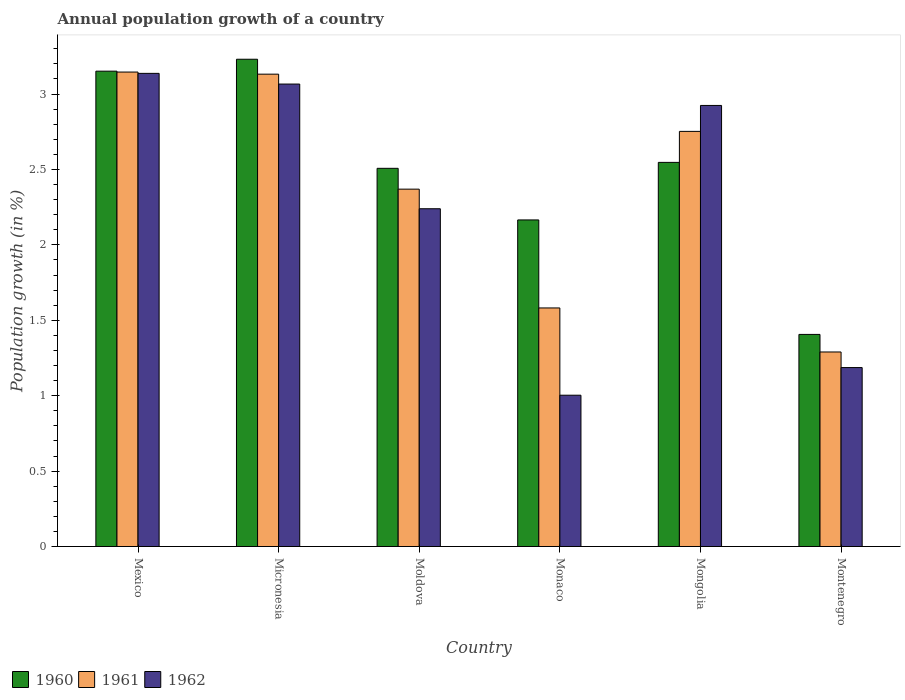How many groups of bars are there?
Provide a succinct answer. 6. Are the number of bars per tick equal to the number of legend labels?
Provide a short and direct response. Yes. Are the number of bars on each tick of the X-axis equal?
Ensure brevity in your answer.  Yes. How many bars are there on the 1st tick from the right?
Offer a very short reply. 3. What is the annual population growth in 1960 in Micronesia?
Provide a succinct answer. 3.23. Across all countries, what is the maximum annual population growth in 1962?
Offer a very short reply. 3.14. Across all countries, what is the minimum annual population growth in 1962?
Your response must be concise. 1. In which country was the annual population growth in 1960 maximum?
Make the answer very short. Micronesia. In which country was the annual population growth in 1962 minimum?
Offer a very short reply. Monaco. What is the total annual population growth in 1960 in the graph?
Keep it short and to the point. 15.01. What is the difference between the annual population growth in 1960 in Moldova and that in Montenegro?
Keep it short and to the point. 1.1. What is the difference between the annual population growth in 1961 in Micronesia and the annual population growth in 1962 in Mongolia?
Your response must be concise. 0.21. What is the average annual population growth in 1960 per country?
Provide a short and direct response. 2.5. What is the difference between the annual population growth of/in 1961 and annual population growth of/in 1962 in Micronesia?
Give a very brief answer. 0.07. In how many countries, is the annual population growth in 1962 greater than 1.4 %?
Your response must be concise. 4. What is the ratio of the annual population growth in 1962 in Mongolia to that in Montenegro?
Offer a terse response. 2.46. Is the annual population growth in 1961 in Moldova less than that in Mongolia?
Offer a terse response. Yes. What is the difference between the highest and the second highest annual population growth in 1960?
Keep it short and to the point. 0.6. What is the difference between the highest and the lowest annual population growth in 1960?
Keep it short and to the point. 1.82. In how many countries, is the annual population growth in 1962 greater than the average annual population growth in 1962 taken over all countries?
Give a very brief answer. 3. What does the 1st bar from the right in Mexico represents?
Provide a succinct answer. 1962. Is it the case that in every country, the sum of the annual population growth in 1960 and annual population growth in 1962 is greater than the annual population growth in 1961?
Offer a terse response. Yes. How many bars are there?
Offer a terse response. 18. Are all the bars in the graph horizontal?
Your answer should be very brief. No. Does the graph contain any zero values?
Make the answer very short. No. Does the graph contain grids?
Your answer should be compact. No. Where does the legend appear in the graph?
Offer a very short reply. Bottom left. How many legend labels are there?
Provide a succinct answer. 3. How are the legend labels stacked?
Your answer should be compact. Horizontal. What is the title of the graph?
Offer a terse response. Annual population growth of a country. Does "1971" appear as one of the legend labels in the graph?
Ensure brevity in your answer.  No. What is the label or title of the Y-axis?
Your response must be concise. Population growth (in %). What is the Population growth (in %) in 1960 in Mexico?
Offer a very short reply. 3.15. What is the Population growth (in %) of 1961 in Mexico?
Offer a very short reply. 3.15. What is the Population growth (in %) in 1962 in Mexico?
Keep it short and to the point. 3.14. What is the Population growth (in %) in 1960 in Micronesia?
Give a very brief answer. 3.23. What is the Population growth (in %) in 1961 in Micronesia?
Give a very brief answer. 3.13. What is the Population growth (in %) in 1962 in Micronesia?
Your answer should be compact. 3.07. What is the Population growth (in %) of 1960 in Moldova?
Keep it short and to the point. 2.51. What is the Population growth (in %) of 1961 in Moldova?
Give a very brief answer. 2.37. What is the Population growth (in %) of 1962 in Moldova?
Ensure brevity in your answer.  2.24. What is the Population growth (in %) in 1960 in Monaco?
Provide a short and direct response. 2.17. What is the Population growth (in %) of 1961 in Monaco?
Your answer should be very brief. 1.58. What is the Population growth (in %) of 1962 in Monaco?
Offer a terse response. 1. What is the Population growth (in %) of 1960 in Mongolia?
Give a very brief answer. 2.55. What is the Population growth (in %) in 1961 in Mongolia?
Your response must be concise. 2.75. What is the Population growth (in %) in 1962 in Mongolia?
Your answer should be compact. 2.92. What is the Population growth (in %) of 1960 in Montenegro?
Your answer should be very brief. 1.41. What is the Population growth (in %) in 1961 in Montenegro?
Offer a terse response. 1.29. What is the Population growth (in %) of 1962 in Montenegro?
Your response must be concise. 1.19. Across all countries, what is the maximum Population growth (in %) of 1960?
Keep it short and to the point. 3.23. Across all countries, what is the maximum Population growth (in %) in 1961?
Provide a short and direct response. 3.15. Across all countries, what is the maximum Population growth (in %) in 1962?
Make the answer very short. 3.14. Across all countries, what is the minimum Population growth (in %) of 1960?
Your response must be concise. 1.41. Across all countries, what is the minimum Population growth (in %) of 1961?
Your answer should be compact. 1.29. Across all countries, what is the minimum Population growth (in %) of 1962?
Ensure brevity in your answer.  1. What is the total Population growth (in %) of 1960 in the graph?
Make the answer very short. 15.01. What is the total Population growth (in %) of 1961 in the graph?
Your answer should be very brief. 14.27. What is the total Population growth (in %) in 1962 in the graph?
Ensure brevity in your answer.  13.56. What is the difference between the Population growth (in %) in 1960 in Mexico and that in Micronesia?
Provide a succinct answer. -0.08. What is the difference between the Population growth (in %) of 1961 in Mexico and that in Micronesia?
Your answer should be very brief. 0.01. What is the difference between the Population growth (in %) in 1962 in Mexico and that in Micronesia?
Provide a short and direct response. 0.07. What is the difference between the Population growth (in %) in 1960 in Mexico and that in Moldova?
Provide a short and direct response. 0.64. What is the difference between the Population growth (in %) of 1961 in Mexico and that in Moldova?
Provide a short and direct response. 0.78. What is the difference between the Population growth (in %) in 1962 in Mexico and that in Moldova?
Make the answer very short. 0.9. What is the difference between the Population growth (in %) of 1960 in Mexico and that in Monaco?
Ensure brevity in your answer.  0.99. What is the difference between the Population growth (in %) of 1961 in Mexico and that in Monaco?
Provide a short and direct response. 1.56. What is the difference between the Population growth (in %) of 1962 in Mexico and that in Monaco?
Give a very brief answer. 2.13. What is the difference between the Population growth (in %) of 1960 in Mexico and that in Mongolia?
Ensure brevity in your answer.  0.6. What is the difference between the Population growth (in %) of 1961 in Mexico and that in Mongolia?
Offer a terse response. 0.39. What is the difference between the Population growth (in %) in 1962 in Mexico and that in Mongolia?
Make the answer very short. 0.21. What is the difference between the Population growth (in %) of 1960 in Mexico and that in Montenegro?
Your response must be concise. 1.75. What is the difference between the Population growth (in %) in 1961 in Mexico and that in Montenegro?
Offer a very short reply. 1.86. What is the difference between the Population growth (in %) of 1962 in Mexico and that in Montenegro?
Offer a very short reply. 1.95. What is the difference between the Population growth (in %) in 1960 in Micronesia and that in Moldova?
Offer a very short reply. 0.72. What is the difference between the Population growth (in %) of 1961 in Micronesia and that in Moldova?
Make the answer very short. 0.76. What is the difference between the Population growth (in %) of 1962 in Micronesia and that in Moldova?
Offer a very short reply. 0.83. What is the difference between the Population growth (in %) in 1960 in Micronesia and that in Monaco?
Your answer should be compact. 1.07. What is the difference between the Population growth (in %) of 1961 in Micronesia and that in Monaco?
Your answer should be very brief. 1.55. What is the difference between the Population growth (in %) of 1962 in Micronesia and that in Monaco?
Offer a very short reply. 2.06. What is the difference between the Population growth (in %) of 1960 in Micronesia and that in Mongolia?
Ensure brevity in your answer.  0.68. What is the difference between the Population growth (in %) of 1961 in Micronesia and that in Mongolia?
Give a very brief answer. 0.38. What is the difference between the Population growth (in %) of 1962 in Micronesia and that in Mongolia?
Your answer should be compact. 0.14. What is the difference between the Population growth (in %) in 1960 in Micronesia and that in Montenegro?
Give a very brief answer. 1.82. What is the difference between the Population growth (in %) in 1961 in Micronesia and that in Montenegro?
Your answer should be compact. 1.84. What is the difference between the Population growth (in %) of 1962 in Micronesia and that in Montenegro?
Ensure brevity in your answer.  1.88. What is the difference between the Population growth (in %) of 1960 in Moldova and that in Monaco?
Give a very brief answer. 0.34. What is the difference between the Population growth (in %) in 1961 in Moldova and that in Monaco?
Your answer should be compact. 0.79. What is the difference between the Population growth (in %) of 1962 in Moldova and that in Monaco?
Make the answer very short. 1.24. What is the difference between the Population growth (in %) of 1960 in Moldova and that in Mongolia?
Your answer should be compact. -0.04. What is the difference between the Population growth (in %) of 1961 in Moldova and that in Mongolia?
Keep it short and to the point. -0.38. What is the difference between the Population growth (in %) in 1962 in Moldova and that in Mongolia?
Your answer should be very brief. -0.68. What is the difference between the Population growth (in %) of 1960 in Moldova and that in Montenegro?
Your response must be concise. 1.1. What is the difference between the Population growth (in %) of 1961 in Moldova and that in Montenegro?
Offer a terse response. 1.08. What is the difference between the Population growth (in %) of 1962 in Moldova and that in Montenegro?
Ensure brevity in your answer.  1.05. What is the difference between the Population growth (in %) in 1960 in Monaco and that in Mongolia?
Provide a short and direct response. -0.38. What is the difference between the Population growth (in %) of 1961 in Monaco and that in Mongolia?
Give a very brief answer. -1.17. What is the difference between the Population growth (in %) in 1962 in Monaco and that in Mongolia?
Offer a very short reply. -1.92. What is the difference between the Population growth (in %) of 1960 in Monaco and that in Montenegro?
Ensure brevity in your answer.  0.76. What is the difference between the Population growth (in %) of 1961 in Monaco and that in Montenegro?
Make the answer very short. 0.29. What is the difference between the Population growth (in %) in 1962 in Monaco and that in Montenegro?
Offer a terse response. -0.18. What is the difference between the Population growth (in %) in 1960 in Mongolia and that in Montenegro?
Keep it short and to the point. 1.14. What is the difference between the Population growth (in %) in 1961 in Mongolia and that in Montenegro?
Offer a very short reply. 1.46. What is the difference between the Population growth (in %) in 1962 in Mongolia and that in Montenegro?
Offer a terse response. 1.74. What is the difference between the Population growth (in %) of 1960 in Mexico and the Population growth (in %) of 1961 in Micronesia?
Provide a succinct answer. 0.02. What is the difference between the Population growth (in %) in 1960 in Mexico and the Population growth (in %) in 1962 in Micronesia?
Provide a succinct answer. 0.09. What is the difference between the Population growth (in %) in 1961 in Mexico and the Population growth (in %) in 1962 in Micronesia?
Your response must be concise. 0.08. What is the difference between the Population growth (in %) of 1960 in Mexico and the Population growth (in %) of 1961 in Moldova?
Your answer should be compact. 0.78. What is the difference between the Population growth (in %) of 1960 in Mexico and the Population growth (in %) of 1962 in Moldova?
Your answer should be very brief. 0.91. What is the difference between the Population growth (in %) in 1961 in Mexico and the Population growth (in %) in 1962 in Moldova?
Ensure brevity in your answer.  0.91. What is the difference between the Population growth (in %) in 1960 in Mexico and the Population growth (in %) in 1961 in Monaco?
Offer a terse response. 1.57. What is the difference between the Population growth (in %) of 1960 in Mexico and the Population growth (in %) of 1962 in Monaco?
Provide a succinct answer. 2.15. What is the difference between the Population growth (in %) in 1961 in Mexico and the Population growth (in %) in 1962 in Monaco?
Provide a succinct answer. 2.14. What is the difference between the Population growth (in %) in 1960 in Mexico and the Population growth (in %) in 1961 in Mongolia?
Offer a terse response. 0.4. What is the difference between the Population growth (in %) of 1960 in Mexico and the Population growth (in %) of 1962 in Mongolia?
Give a very brief answer. 0.23. What is the difference between the Population growth (in %) in 1961 in Mexico and the Population growth (in %) in 1962 in Mongolia?
Your response must be concise. 0.22. What is the difference between the Population growth (in %) of 1960 in Mexico and the Population growth (in %) of 1961 in Montenegro?
Offer a terse response. 1.86. What is the difference between the Population growth (in %) in 1960 in Mexico and the Population growth (in %) in 1962 in Montenegro?
Your answer should be compact. 1.97. What is the difference between the Population growth (in %) in 1961 in Mexico and the Population growth (in %) in 1962 in Montenegro?
Provide a succinct answer. 1.96. What is the difference between the Population growth (in %) in 1960 in Micronesia and the Population growth (in %) in 1961 in Moldova?
Provide a short and direct response. 0.86. What is the difference between the Population growth (in %) of 1961 in Micronesia and the Population growth (in %) of 1962 in Moldova?
Your answer should be compact. 0.89. What is the difference between the Population growth (in %) of 1960 in Micronesia and the Population growth (in %) of 1961 in Monaco?
Ensure brevity in your answer.  1.65. What is the difference between the Population growth (in %) of 1960 in Micronesia and the Population growth (in %) of 1962 in Monaco?
Offer a terse response. 2.23. What is the difference between the Population growth (in %) in 1961 in Micronesia and the Population growth (in %) in 1962 in Monaco?
Keep it short and to the point. 2.13. What is the difference between the Population growth (in %) in 1960 in Micronesia and the Population growth (in %) in 1961 in Mongolia?
Ensure brevity in your answer.  0.48. What is the difference between the Population growth (in %) of 1960 in Micronesia and the Population growth (in %) of 1962 in Mongolia?
Your response must be concise. 0.31. What is the difference between the Population growth (in %) of 1961 in Micronesia and the Population growth (in %) of 1962 in Mongolia?
Ensure brevity in your answer.  0.21. What is the difference between the Population growth (in %) in 1960 in Micronesia and the Population growth (in %) in 1961 in Montenegro?
Ensure brevity in your answer.  1.94. What is the difference between the Population growth (in %) of 1960 in Micronesia and the Population growth (in %) of 1962 in Montenegro?
Make the answer very short. 2.04. What is the difference between the Population growth (in %) in 1961 in Micronesia and the Population growth (in %) in 1962 in Montenegro?
Keep it short and to the point. 1.95. What is the difference between the Population growth (in %) of 1960 in Moldova and the Population growth (in %) of 1961 in Monaco?
Keep it short and to the point. 0.93. What is the difference between the Population growth (in %) in 1960 in Moldova and the Population growth (in %) in 1962 in Monaco?
Provide a short and direct response. 1.5. What is the difference between the Population growth (in %) in 1961 in Moldova and the Population growth (in %) in 1962 in Monaco?
Offer a very short reply. 1.37. What is the difference between the Population growth (in %) of 1960 in Moldova and the Population growth (in %) of 1961 in Mongolia?
Offer a terse response. -0.24. What is the difference between the Population growth (in %) of 1960 in Moldova and the Population growth (in %) of 1962 in Mongolia?
Your answer should be very brief. -0.42. What is the difference between the Population growth (in %) in 1961 in Moldova and the Population growth (in %) in 1962 in Mongolia?
Provide a short and direct response. -0.56. What is the difference between the Population growth (in %) in 1960 in Moldova and the Population growth (in %) in 1961 in Montenegro?
Your answer should be compact. 1.22. What is the difference between the Population growth (in %) in 1960 in Moldova and the Population growth (in %) in 1962 in Montenegro?
Provide a short and direct response. 1.32. What is the difference between the Population growth (in %) of 1961 in Moldova and the Population growth (in %) of 1962 in Montenegro?
Offer a very short reply. 1.18. What is the difference between the Population growth (in %) in 1960 in Monaco and the Population growth (in %) in 1961 in Mongolia?
Your answer should be very brief. -0.59. What is the difference between the Population growth (in %) of 1960 in Monaco and the Population growth (in %) of 1962 in Mongolia?
Your response must be concise. -0.76. What is the difference between the Population growth (in %) of 1961 in Monaco and the Population growth (in %) of 1962 in Mongolia?
Keep it short and to the point. -1.34. What is the difference between the Population growth (in %) in 1960 in Monaco and the Population growth (in %) in 1961 in Montenegro?
Give a very brief answer. 0.88. What is the difference between the Population growth (in %) of 1960 in Monaco and the Population growth (in %) of 1962 in Montenegro?
Your answer should be compact. 0.98. What is the difference between the Population growth (in %) of 1961 in Monaco and the Population growth (in %) of 1962 in Montenegro?
Offer a terse response. 0.4. What is the difference between the Population growth (in %) of 1960 in Mongolia and the Population growth (in %) of 1961 in Montenegro?
Keep it short and to the point. 1.26. What is the difference between the Population growth (in %) in 1960 in Mongolia and the Population growth (in %) in 1962 in Montenegro?
Your answer should be compact. 1.36. What is the difference between the Population growth (in %) of 1961 in Mongolia and the Population growth (in %) of 1962 in Montenegro?
Your answer should be very brief. 1.57. What is the average Population growth (in %) in 1960 per country?
Provide a succinct answer. 2.5. What is the average Population growth (in %) of 1961 per country?
Provide a succinct answer. 2.38. What is the average Population growth (in %) of 1962 per country?
Offer a very short reply. 2.26. What is the difference between the Population growth (in %) of 1960 and Population growth (in %) of 1961 in Mexico?
Keep it short and to the point. 0.01. What is the difference between the Population growth (in %) in 1960 and Population growth (in %) in 1962 in Mexico?
Make the answer very short. 0.01. What is the difference between the Population growth (in %) of 1961 and Population growth (in %) of 1962 in Mexico?
Offer a terse response. 0.01. What is the difference between the Population growth (in %) of 1960 and Population growth (in %) of 1961 in Micronesia?
Provide a short and direct response. 0.1. What is the difference between the Population growth (in %) of 1960 and Population growth (in %) of 1962 in Micronesia?
Your answer should be compact. 0.16. What is the difference between the Population growth (in %) in 1961 and Population growth (in %) in 1962 in Micronesia?
Your answer should be compact. 0.07. What is the difference between the Population growth (in %) of 1960 and Population growth (in %) of 1961 in Moldova?
Keep it short and to the point. 0.14. What is the difference between the Population growth (in %) of 1960 and Population growth (in %) of 1962 in Moldova?
Your response must be concise. 0.27. What is the difference between the Population growth (in %) in 1961 and Population growth (in %) in 1962 in Moldova?
Offer a terse response. 0.13. What is the difference between the Population growth (in %) of 1960 and Population growth (in %) of 1961 in Monaco?
Keep it short and to the point. 0.58. What is the difference between the Population growth (in %) of 1960 and Population growth (in %) of 1962 in Monaco?
Keep it short and to the point. 1.16. What is the difference between the Population growth (in %) in 1961 and Population growth (in %) in 1962 in Monaco?
Your response must be concise. 0.58. What is the difference between the Population growth (in %) of 1960 and Population growth (in %) of 1961 in Mongolia?
Provide a succinct answer. -0.21. What is the difference between the Population growth (in %) in 1960 and Population growth (in %) in 1962 in Mongolia?
Your answer should be compact. -0.38. What is the difference between the Population growth (in %) of 1961 and Population growth (in %) of 1962 in Mongolia?
Your answer should be very brief. -0.17. What is the difference between the Population growth (in %) of 1960 and Population growth (in %) of 1961 in Montenegro?
Offer a terse response. 0.12. What is the difference between the Population growth (in %) of 1960 and Population growth (in %) of 1962 in Montenegro?
Ensure brevity in your answer.  0.22. What is the difference between the Population growth (in %) in 1961 and Population growth (in %) in 1962 in Montenegro?
Give a very brief answer. 0.1. What is the ratio of the Population growth (in %) of 1960 in Mexico to that in Micronesia?
Offer a terse response. 0.98. What is the ratio of the Population growth (in %) of 1961 in Mexico to that in Micronesia?
Your response must be concise. 1. What is the ratio of the Population growth (in %) in 1962 in Mexico to that in Micronesia?
Keep it short and to the point. 1.02. What is the ratio of the Population growth (in %) in 1960 in Mexico to that in Moldova?
Make the answer very short. 1.26. What is the ratio of the Population growth (in %) in 1961 in Mexico to that in Moldova?
Offer a terse response. 1.33. What is the ratio of the Population growth (in %) in 1962 in Mexico to that in Moldova?
Ensure brevity in your answer.  1.4. What is the ratio of the Population growth (in %) of 1960 in Mexico to that in Monaco?
Your answer should be compact. 1.46. What is the ratio of the Population growth (in %) in 1961 in Mexico to that in Monaco?
Your response must be concise. 1.99. What is the ratio of the Population growth (in %) of 1962 in Mexico to that in Monaco?
Keep it short and to the point. 3.13. What is the ratio of the Population growth (in %) of 1960 in Mexico to that in Mongolia?
Your response must be concise. 1.24. What is the ratio of the Population growth (in %) of 1961 in Mexico to that in Mongolia?
Keep it short and to the point. 1.14. What is the ratio of the Population growth (in %) in 1962 in Mexico to that in Mongolia?
Keep it short and to the point. 1.07. What is the ratio of the Population growth (in %) of 1960 in Mexico to that in Montenegro?
Make the answer very short. 2.24. What is the ratio of the Population growth (in %) in 1961 in Mexico to that in Montenegro?
Make the answer very short. 2.44. What is the ratio of the Population growth (in %) in 1962 in Mexico to that in Montenegro?
Offer a terse response. 2.64. What is the ratio of the Population growth (in %) of 1960 in Micronesia to that in Moldova?
Your answer should be very brief. 1.29. What is the ratio of the Population growth (in %) in 1961 in Micronesia to that in Moldova?
Offer a terse response. 1.32. What is the ratio of the Population growth (in %) of 1962 in Micronesia to that in Moldova?
Offer a terse response. 1.37. What is the ratio of the Population growth (in %) of 1960 in Micronesia to that in Monaco?
Make the answer very short. 1.49. What is the ratio of the Population growth (in %) of 1961 in Micronesia to that in Monaco?
Your answer should be very brief. 1.98. What is the ratio of the Population growth (in %) in 1962 in Micronesia to that in Monaco?
Offer a terse response. 3.06. What is the ratio of the Population growth (in %) of 1960 in Micronesia to that in Mongolia?
Offer a terse response. 1.27. What is the ratio of the Population growth (in %) of 1961 in Micronesia to that in Mongolia?
Offer a very short reply. 1.14. What is the ratio of the Population growth (in %) in 1962 in Micronesia to that in Mongolia?
Provide a succinct answer. 1.05. What is the ratio of the Population growth (in %) of 1960 in Micronesia to that in Montenegro?
Provide a succinct answer. 2.3. What is the ratio of the Population growth (in %) in 1961 in Micronesia to that in Montenegro?
Provide a succinct answer. 2.43. What is the ratio of the Population growth (in %) in 1962 in Micronesia to that in Montenegro?
Offer a very short reply. 2.58. What is the ratio of the Population growth (in %) in 1960 in Moldova to that in Monaco?
Make the answer very short. 1.16. What is the ratio of the Population growth (in %) in 1961 in Moldova to that in Monaco?
Your answer should be compact. 1.5. What is the ratio of the Population growth (in %) of 1962 in Moldova to that in Monaco?
Provide a succinct answer. 2.23. What is the ratio of the Population growth (in %) of 1960 in Moldova to that in Mongolia?
Ensure brevity in your answer.  0.98. What is the ratio of the Population growth (in %) of 1961 in Moldova to that in Mongolia?
Your response must be concise. 0.86. What is the ratio of the Population growth (in %) in 1962 in Moldova to that in Mongolia?
Ensure brevity in your answer.  0.77. What is the ratio of the Population growth (in %) of 1960 in Moldova to that in Montenegro?
Ensure brevity in your answer.  1.78. What is the ratio of the Population growth (in %) in 1961 in Moldova to that in Montenegro?
Offer a very short reply. 1.84. What is the ratio of the Population growth (in %) of 1962 in Moldova to that in Montenegro?
Offer a very short reply. 1.89. What is the ratio of the Population growth (in %) of 1960 in Monaco to that in Mongolia?
Your response must be concise. 0.85. What is the ratio of the Population growth (in %) in 1961 in Monaco to that in Mongolia?
Offer a very short reply. 0.57. What is the ratio of the Population growth (in %) in 1962 in Monaco to that in Mongolia?
Your response must be concise. 0.34. What is the ratio of the Population growth (in %) in 1960 in Monaco to that in Montenegro?
Offer a very short reply. 1.54. What is the ratio of the Population growth (in %) in 1961 in Monaco to that in Montenegro?
Make the answer very short. 1.23. What is the ratio of the Population growth (in %) in 1962 in Monaco to that in Montenegro?
Your response must be concise. 0.85. What is the ratio of the Population growth (in %) in 1960 in Mongolia to that in Montenegro?
Provide a short and direct response. 1.81. What is the ratio of the Population growth (in %) in 1961 in Mongolia to that in Montenegro?
Keep it short and to the point. 2.13. What is the ratio of the Population growth (in %) in 1962 in Mongolia to that in Montenegro?
Keep it short and to the point. 2.46. What is the difference between the highest and the second highest Population growth (in %) in 1960?
Your response must be concise. 0.08. What is the difference between the highest and the second highest Population growth (in %) in 1961?
Make the answer very short. 0.01. What is the difference between the highest and the second highest Population growth (in %) in 1962?
Your answer should be very brief. 0.07. What is the difference between the highest and the lowest Population growth (in %) of 1960?
Your answer should be compact. 1.82. What is the difference between the highest and the lowest Population growth (in %) of 1961?
Ensure brevity in your answer.  1.86. What is the difference between the highest and the lowest Population growth (in %) of 1962?
Your answer should be very brief. 2.13. 